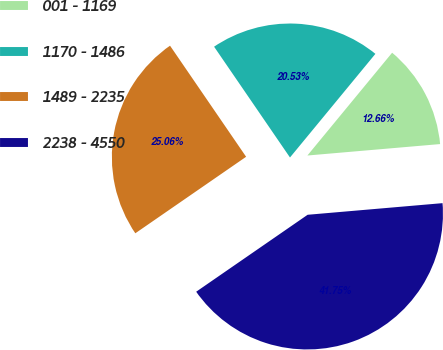Convert chart. <chart><loc_0><loc_0><loc_500><loc_500><pie_chart><fcel>001 - 1169<fcel>1170 - 1486<fcel>1489 - 2235<fcel>2238 - 4550<nl><fcel>12.66%<fcel>20.53%<fcel>25.06%<fcel>41.75%<nl></chart> 